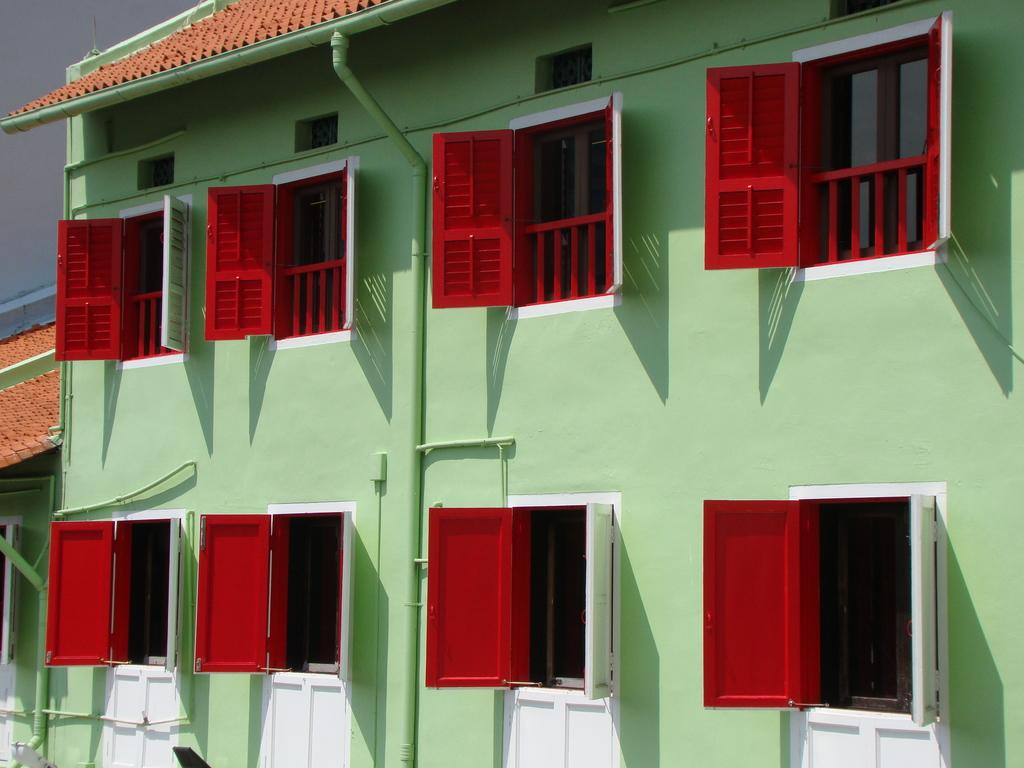What type of structure is present in the image? There is a building in the image. What feature can be seen on the building? The building has windows. What color are the windows? The windows are painted red. What color are the walls of the building? The building walls are painted green. are painted green. What is attached to the wall of the building? There is a pipe attached to the wall. How much sugar is stored in the cellar of the building in the image? There is no information about a cellar or sugar storage in the image. 